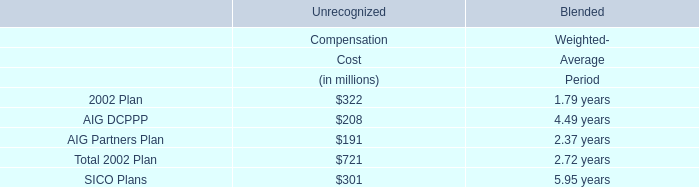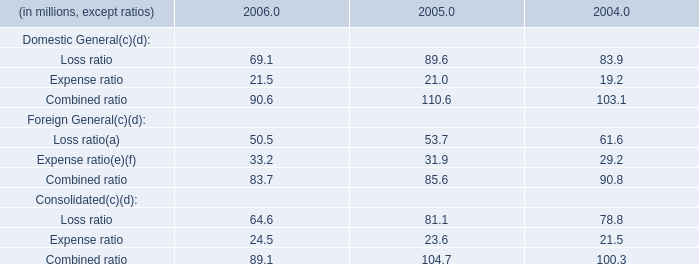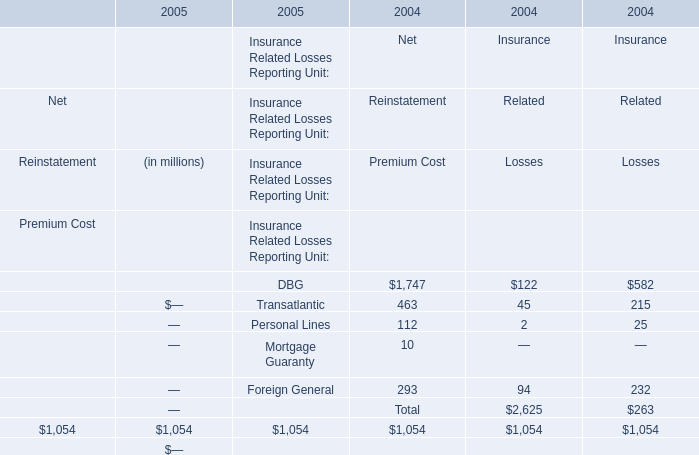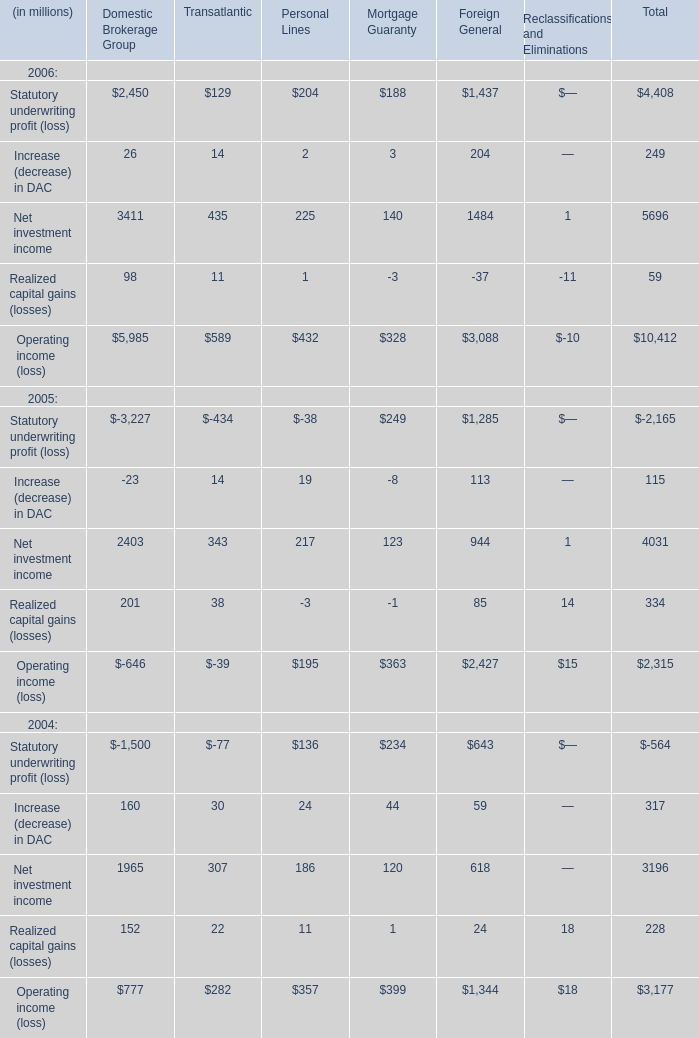What's the sum of Combined ratio of Consolidated without the ratio smaller than 30, in 2006? 
Answer: 64.6. 